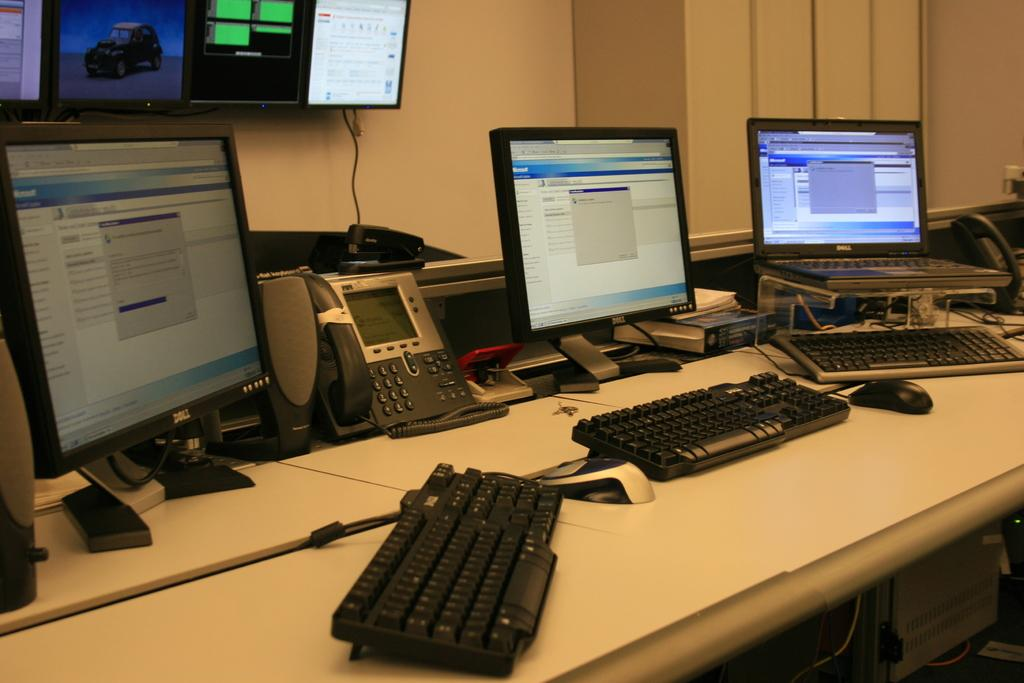What type of electronic devices are on the table in the foreground? There are monitors, keyboards, telephones, and mice on the table in the foreground. What other objects can be seen on the table in the foreground? There are other objects on the table in the foreground, but their specific details are not mentioned in the facts. What is visible on the wall in the background? There is a screen on the wall in the background. What type of wool is being used to cover the beetle in the image? There is no beetle or wool present in the image. What type of system is being used to manage the telephones on the table? The facts do not mention any specific system for managing the telephones on the table. 